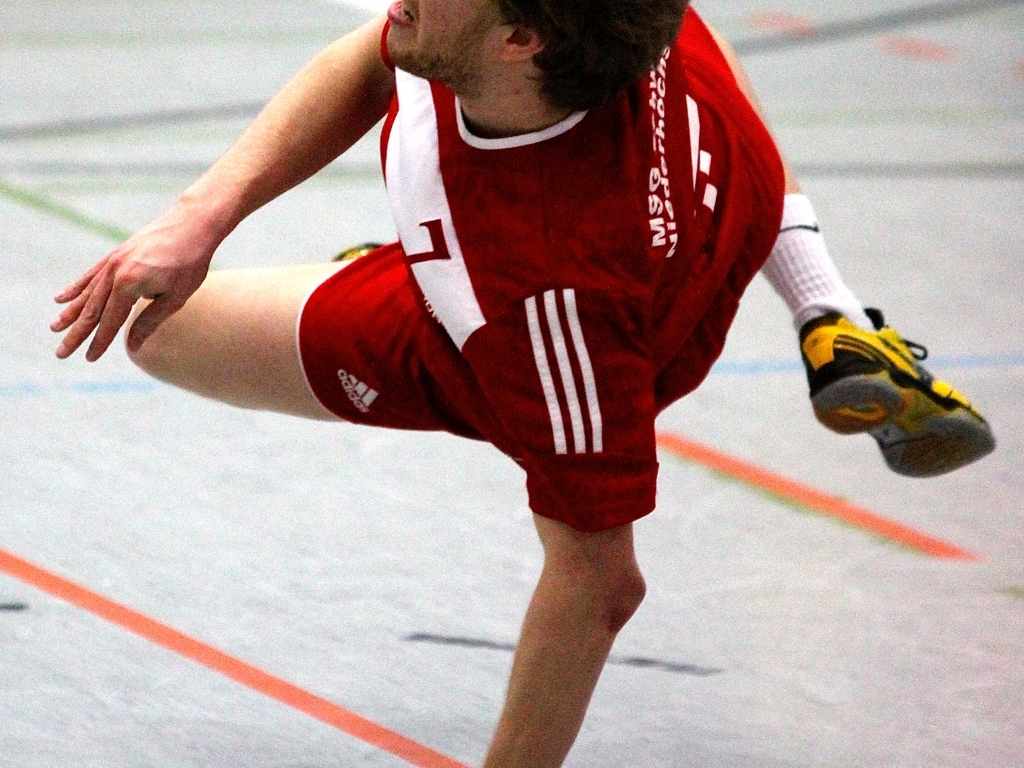Can you tell me more about the technique or action being captured in the photo? The individual appears to be in the midst of a rapid movement, possibly making a play or maneuvering around an opponent. The focus on the legs and the implied motion suggests a high-energy, fast-paced moment typical in competitive sports. 